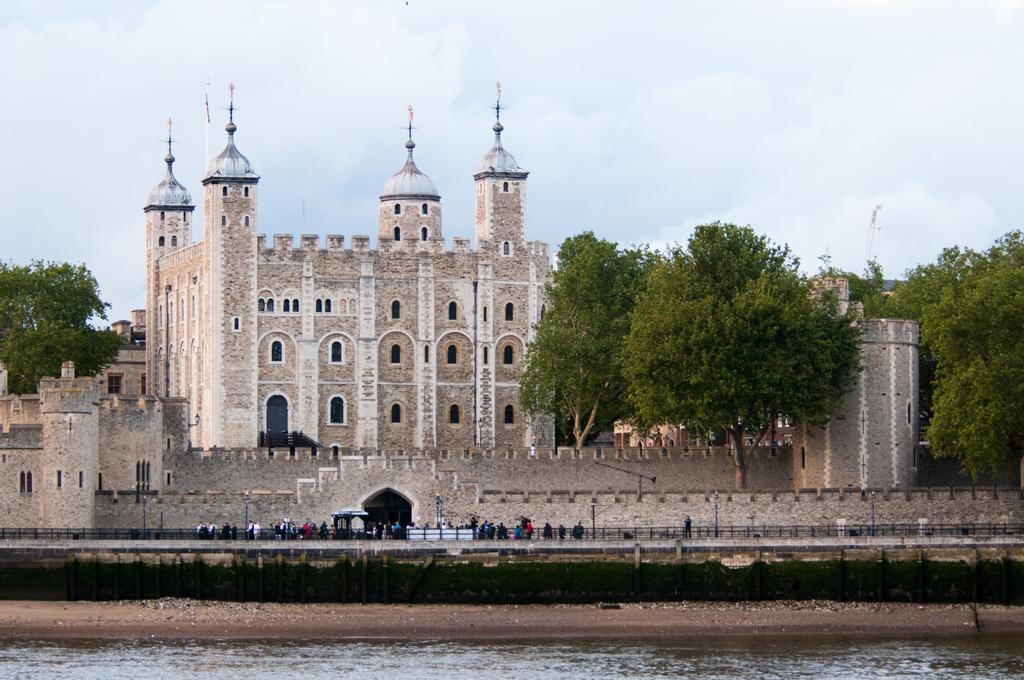Please provide a concise description of this image. In this image I can see water on the bottom side. In the background I can see number of poles, fencing, number of people, few buildings, number of trees, clouds and the sky. 